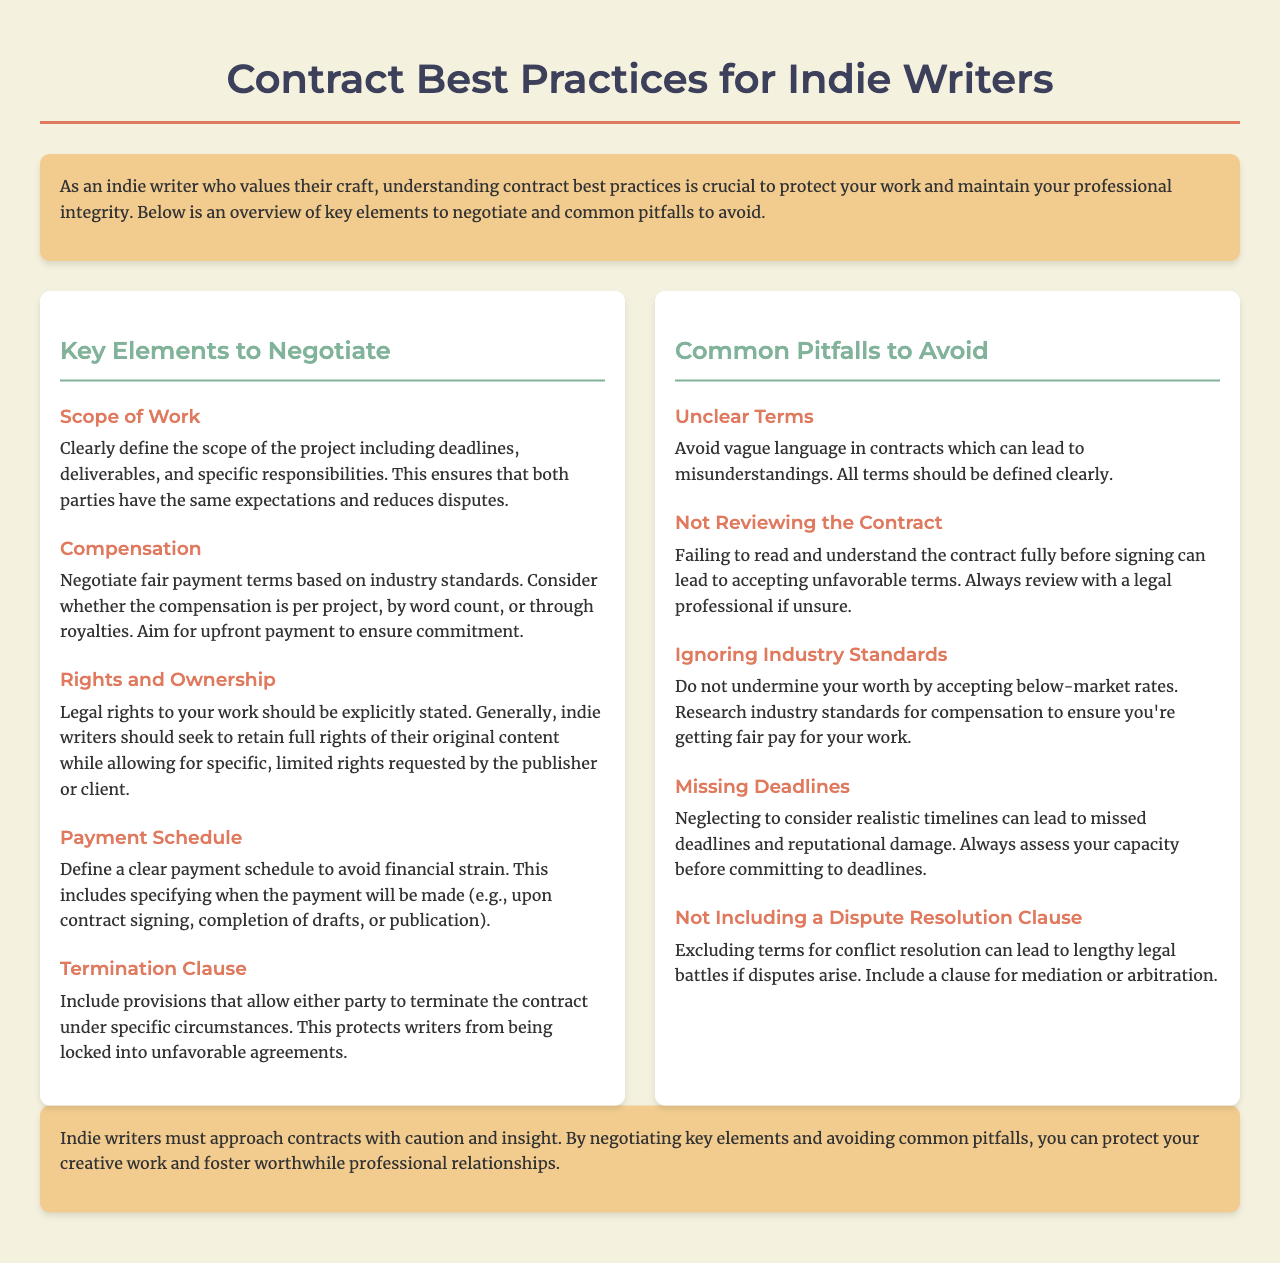what is the title of the document? The title of the document is stated in the header of the HTML and is "Contract Best Practices for Indie Writers."
Answer: Contract Best Practices for Indie Writers how many key elements to negotiate are listed? The document lists five key elements to negotiate under the section "Key Elements to Negotiate."
Answer: 5 what is one key element regarding compensation? The document mentions that compensation should be based on industry standards, with a preference for upfront payment.
Answer: Fair payment terms what should indie writers avoid according to the common pitfalls section? The document outlines five common pitfalls that indie writers should avoid, mentioning vague language and missing deadlines among others.
Answer: Vague language what is a suggestion for termination clauses? The document recommends including provisions that allow either party to terminate the contract under specific circumstances.
Answer: Termination clause which aspect of contracts does the document emphasize for indie writers? The document emphasizes the importance of understanding contract best practices to protect work and maintain professional integrity.
Answer: Understanding contract best practices what does the document state about unrealistic timelines? The document states that neglecting to consider realistic timelines can lead to missed deadlines and reputational damage.
Answer: Missed deadlines what is the proposed inclusion for dispute resolution? The document suggests including a dispute resolution clause to avoid lengthy legal battles if disputes arise.
Answer: Dispute resolution clause 